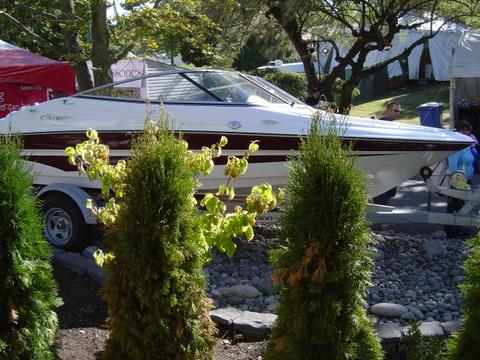What is the closest major city from this outdoor area? Please explain your reasoning. vancouver. The city is vancouver. 